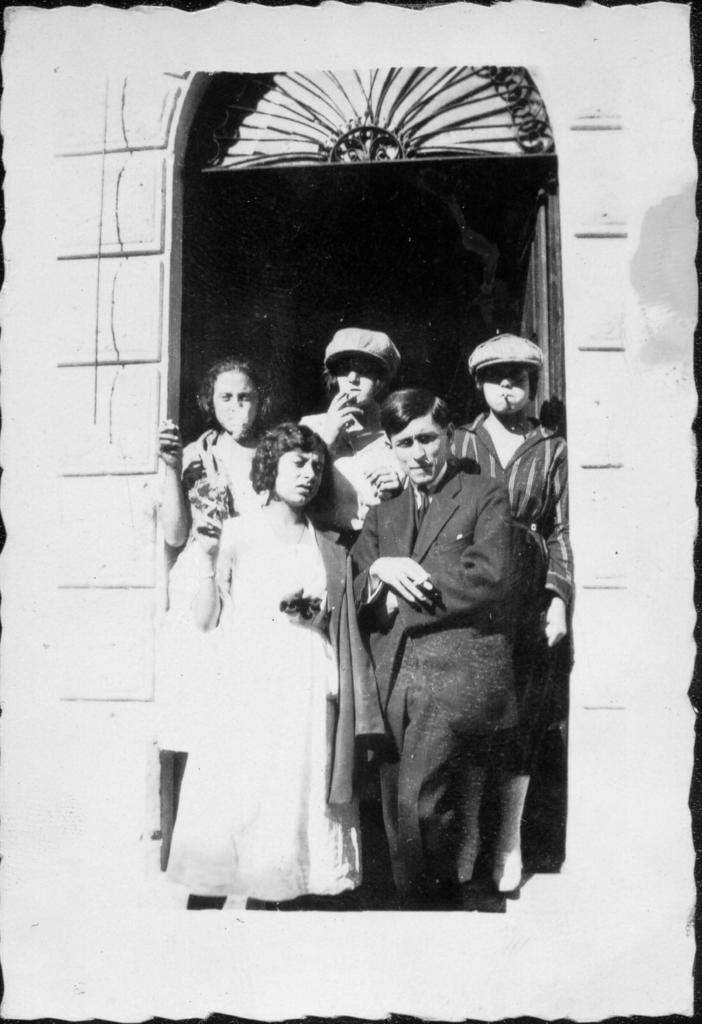What is happening in the building in the image? There are people standing in the building. Where are the people located in relation to the door? The people are near a door. What color scheme is used in the image? The image is in black and white color. Can you see any chickens in the image? There are no chickens present in the image. What type of wool is being used to create the door in the image? The image is in black and white color, and there is no indication of wool being used in the door or any other part of the image. 